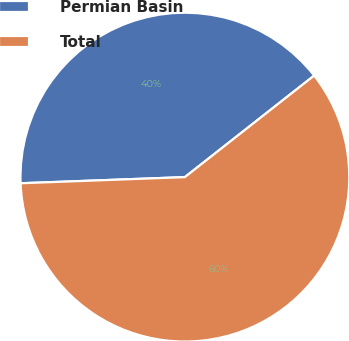Convert chart. <chart><loc_0><loc_0><loc_500><loc_500><pie_chart><fcel>Permian Basin<fcel>Total<nl><fcel>40.0%<fcel>60.0%<nl></chart> 